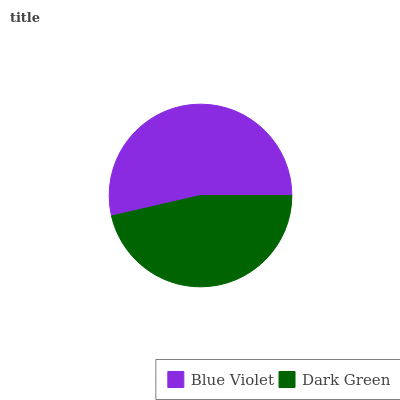Is Dark Green the minimum?
Answer yes or no. Yes. Is Blue Violet the maximum?
Answer yes or no. Yes. Is Dark Green the maximum?
Answer yes or no. No. Is Blue Violet greater than Dark Green?
Answer yes or no. Yes. Is Dark Green less than Blue Violet?
Answer yes or no. Yes. Is Dark Green greater than Blue Violet?
Answer yes or no. No. Is Blue Violet less than Dark Green?
Answer yes or no. No. Is Blue Violet the high median?
Answer yes or no. Yes. Is Dark Green the low median?
Answer yes or no. Yes. Is Dark Green the high median?
Answer yes or no. No. Is Blue Violet the low median?
Answer yes or no. No. 